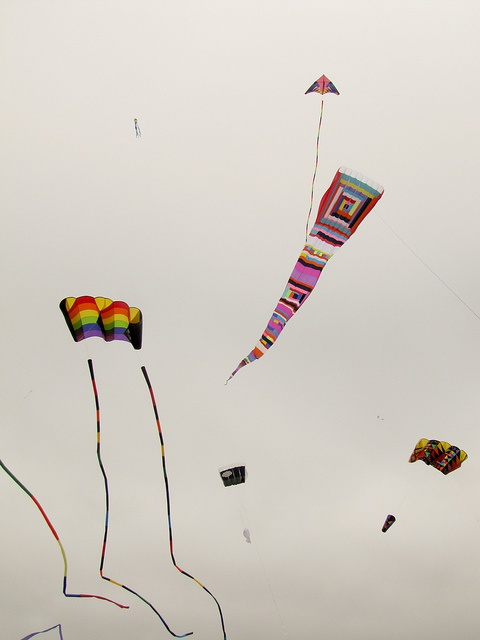Describe the objects in this image and their specific colors. I can see kite in lightgray, black, and darkgray tones, kite in lightgray, brown, black, and teal tones, kite in lightgray, black, maroon, and olive tones, kite in lightgray, black, and darkgray tones, and kite in lightgray, salmon, purple, and brown tones in this image. 